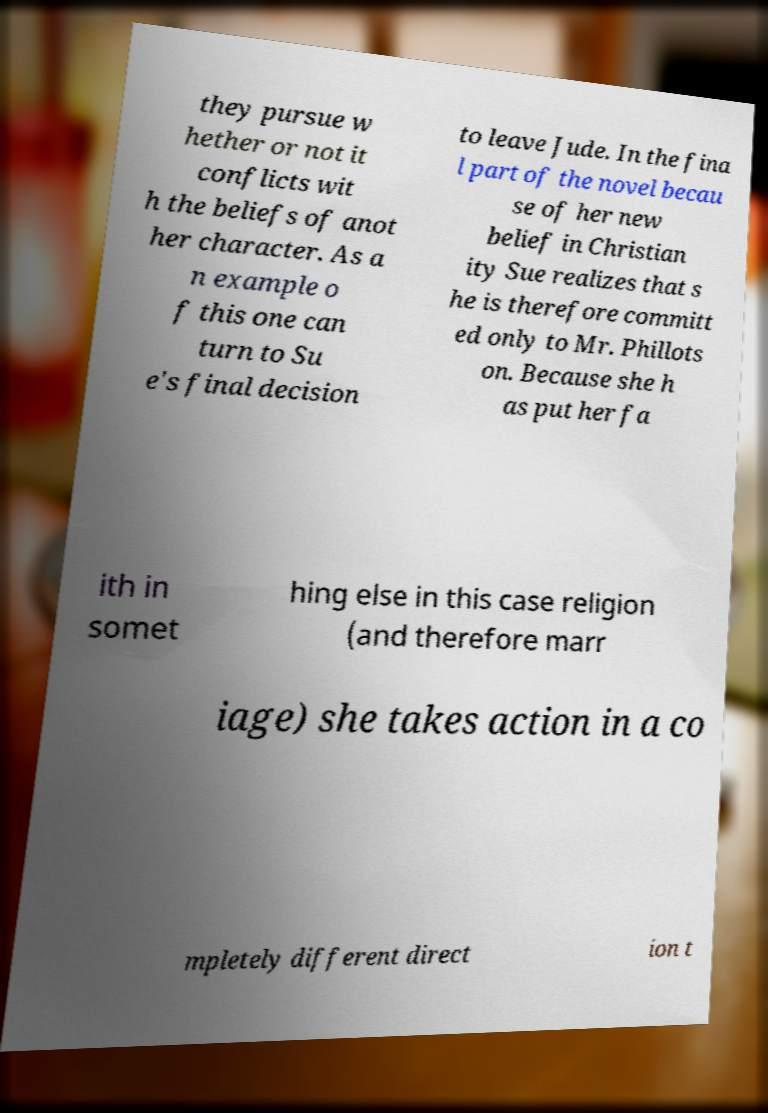There's text embedded in this image that I need extracted. Can you transcribe it verbatim? they pursue w hether or not it conflicts wit h the beliefs of anot her character. As a n example o f this one can turn to Su e's final decision to leave Jude. In the fina l part of the novel becau se of her new belief in Christian ity Sue realizes that s he is therefore committ ed only to Mr. Phillots on. Because she h as put her fa ith in somet hing else in this case religion (and therefore marr iage) she takes action in a co mpletely different direct ion t 